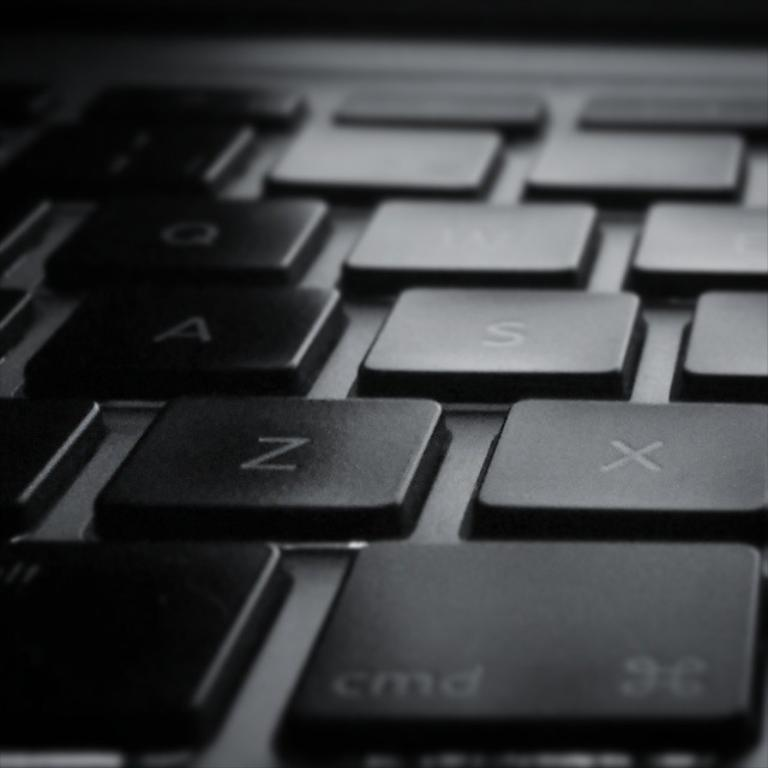<image>
Write a terse but informative summary of the picture. the letter Z is on the computer keyboard 